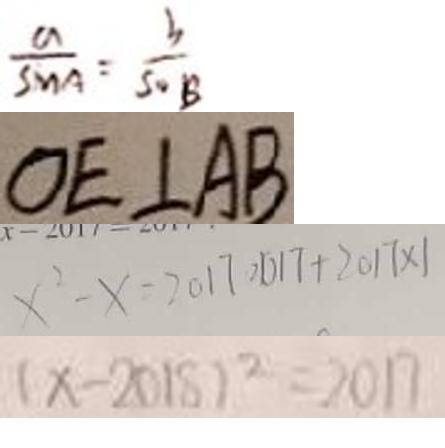Convert formula to latex. <formula><loc_0><loc_0><loc_500><loc_500>\frac { a } { \sin A } = \frac { b } { \sin B } 
 O E \bot A B 
 x ^ { 2 } - x = 2 0 1 7 \cdot 2 0 1 7 + 2 0 1 7 \times 1 
 ( x - 2 0 1 8 ) ^ { 2 } = 2 0 1 7</formula> 